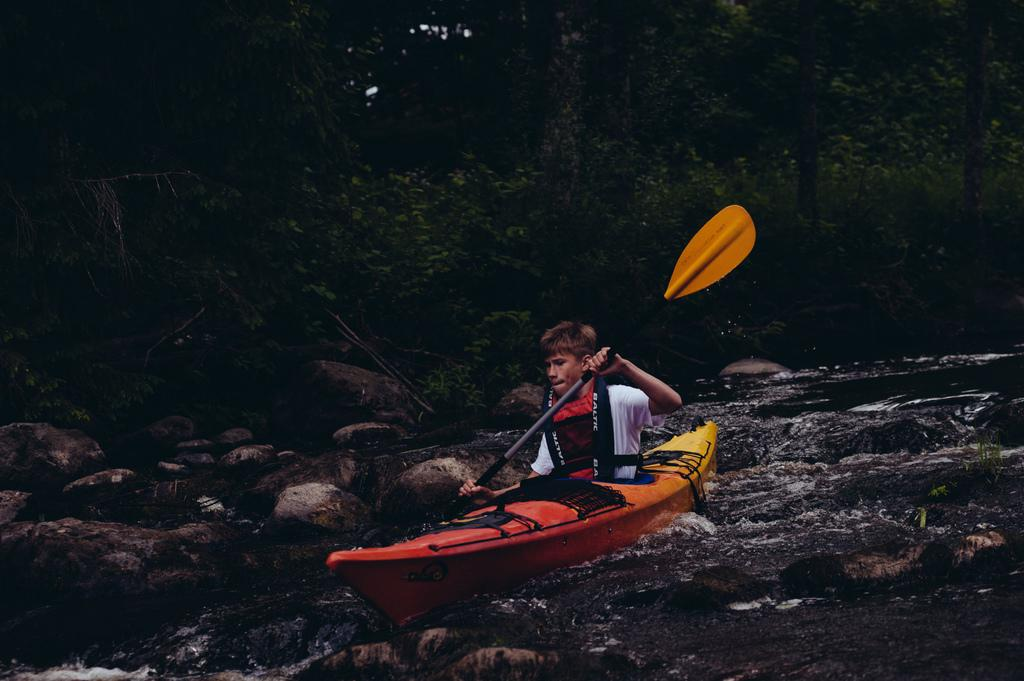What is the main subject of the image? The main subject of the image is a boat. What colors are used for the boat? The boat is yellow and red in color. Who is in the boat? There is a person in the boat. What is the person doing in the boat? The person is holding a paddle. What can be seen in the background of the image? There is water, stones, and trees visible in the image. How many seats are available in the boat for the person to sit on? There is no mention of seats in the image, as the person is standing and holding a paddle. What type of step is required to enter the boat? There is no mention of a step or any specific action required to enter the boat in the image. 